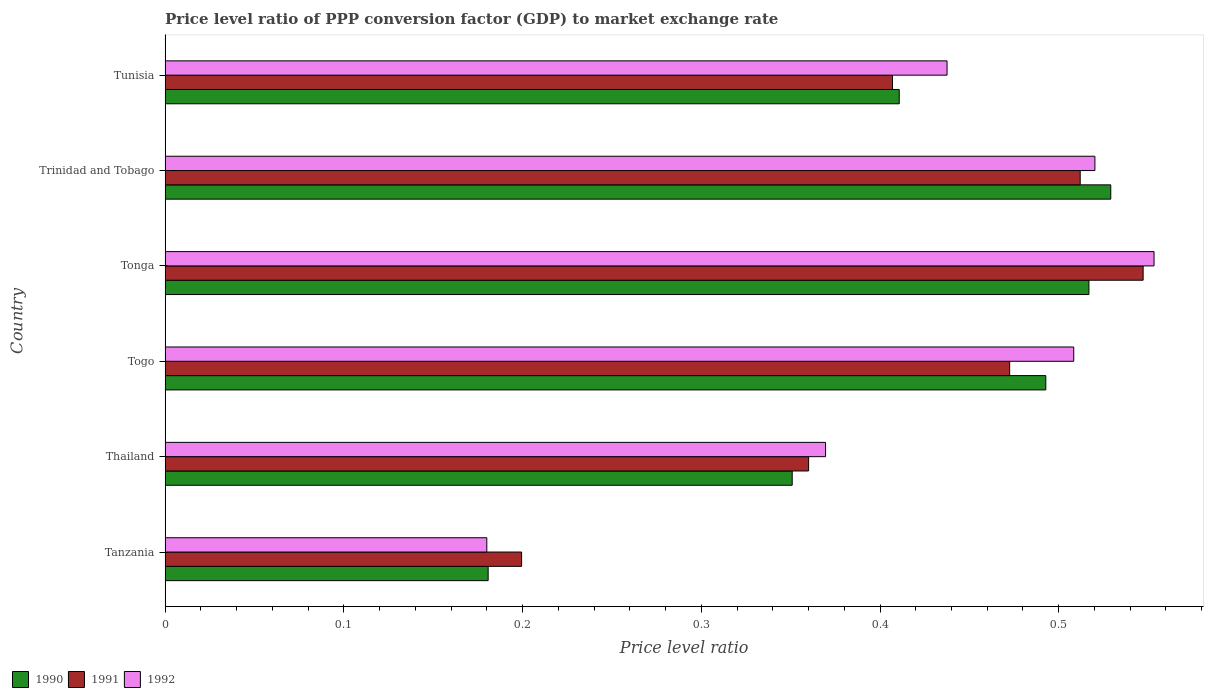How many groups of bars are there?
Your answer should be very brief. 6. Are the number of bars per tick equal to the number of legend labels?
Keep it short and to the point. Yes. Are the number of bars on each tick of the Y-axis equal?
Your response must be concise. Yes. What is the label of the 3rd group of bars from the top?
Ensure brevity in your answer.  Tonga. What is the price level ratio in 1991 in Togo?
Make the answer very short. 0.47. Across all countries, what is the maximum price level ratio in 1992?
Your response must be concise. 0.55. Across all countries, what is the minimum price level ratio in 1991?
Your answer should be very brief. 0.2. In which country was the price level ratio in 1990 maximum?
Offer a terse response. Trinidad and Tobago. In which country was the price level ratio in 1990 minimum?
Ensure brevity in your answer.  Tanzania. What is the total price level ratio in 1990 in the graph?
Your answer should be compact. 2.48. What is the difference between the price level ratio in 1991 in Thailand and that in Tunisia?
Give a very brief answer. -0.05. What is the difference between the price level ratio in 1992 in Tunisia and the price level ratio in 1991 in Trinidad and Tobago?
Keep it short and to the point. -0.07. What is the average price level ratio in 1992 per country?
Ensure brevity in your answer.  0.43. What is the difference between the price level ratio in 1990 and price level ratio in 1992 in Togo?
Ensure brevity in your answer.  -0.02. What is the ratio of the price level ratio in 1990 in Thailand to that in Togo?
Give a very brief answer. 0.71. Is the price level ratio in 1990 in Thailand less than that in Tonga?
Give a very brief answer. Yes. Is the difference between the price level ratio in 1990 in Tanzania and Tonga greater than the difference between the price level ratio in 1992 in Tanzania and Tonga?
Your answer should be compact. Yes. What is the difference between the highest and the second highest price level ratio in 1991?
Your response must be concise. 0.04. What is the difference between the highest and the lowest price level ratio in 1992?
Keep it short and to the point. 0.37. Is the sum of the price level ratio in 1992 in Togo and Trinidad and Tobago greater than the maximum price level ratio in 1991 across all countries?
Your response must be concise. Yes. What does the 3rd bar from the bottom in Tanzania represents?
Your answer should be very brief. 1992. Are all the bars in the graph horizontal?
Make the answer very short. Yes. How many countries are there in the graph?
Keep it short and to the point. 6. What is the difference between two consecutive major ticks on the X-axis?
Provide a short and direct response. 0.1. Does the graph contain any zero values?
Your response must be concise. No. Does the graph contain grids?
Ensure brevity in your answer.  No. Where does the legend appear in the graph?
Your response must be concise. Bottom left. How are the legend labels stacked?
Ensure brevity in your answer.  Horizontal. What is the title of the graph?
Keep it short and to the point. Price level ratio of PPP conversion factor (GDP) to market exchange rate. Does "1975" appear as one of the legend labels in the graph?
Keep it short and to the point. No. What is the label or title of the X-axis?
Give a very brief answer. Price level ratio. What is the label or title of the Y-axis?
Your answer should be very brief. Country. What is the Price level ratio of 1990 in Tanzania?
Make the answer very short. 0.18. What is the Price level ratio of 1991 in Tanzania?
Ensure brevity in your answer.  0.2. What is the Price level ratio in 1992 in Tanzania?
Your answer should be very brief. 0.18. What is the Price level ratio of 1990 in Thailand?
Keep it short and to the point. 0.35. What is the Price level ratio of 1991 in Thailand?
Provide a short and direct response. 0.36. What is the Price level ratio of 1992 in Thailand?
Make the answer very short. 0.37. What is the Price level ratio of 1990 in Togo?
Offer a very short reply. 0.49. What is the Price level ratio of 1991 in Togo?
Give a very brief answer. 0.47. What is the Price level ratio in 1992 in Togo?
Your answer should be compact. 0.51. What is the Price level ratio of 1990 in Tonga?
Ensure brevity in your answer.  0.52. What is the Price level ratio of 1991 in Tonga?
Provide a short and direct response. 0.55. What is the Price level ratio in 1992 in Tonga?
Make the answer very short. 0.55. What is the Price level ratio of 1990 in Trinidad and Tobago?
Offer a terse response. 0.53. What is the Price level ratio in 1991 in Trinidad and Tobago?
Your answer should be compact. 0.51. What is the Price level ratio in 1992 in Trinidad and Tobago?
Provide a succinct answer. 0.52. What is the Price level ratio in 1990 in Tunisia?
Your response must be concise. 0.41. What is the Price level ratio of 1991 in Tunisia?
Offer a very short reply. 0.41. What is the Price level ratio in 1992 in Tunisia?
Provide a short and direct response. 0.44. Across all countries, what is the maximum Price level ratio in 1990?
Offer a terse response. 0.53. Across all countries, what is the maximum Price level ratio of 1991?
Your answer should be very brief. 0.55. Across all countries, what is the maximum Price level ratio of 1992?
Make the answer very short. 0.55. Across all countries, what is the minimum Price level ratio in 1990?
Provide a short and direct response. 0.18. Across all countries, what is the minimum Price level ratio in 1991?
Provide a succinct answer. 0.2. Across all countries, what is the minimum Price level ratio in 1992?
Your answer should be very brief. 0.18. What is the total Price level ratio in 1990 in the graph?
Make the answer very short. 2.48. What is the total Price level ratio of 1991 in the graph?
Provide a short and direct response. 2.5. What is the total Price level ratio of 1992 in the graph?
Provide a succinct answer. 2.57. What is the difference between the Price level ratio of 1990 in Tanzania and that in Thailand?
Provide a short and direct response. -0.17. What is the difference between the Price level ratio of 1991 in Tanzania and that in Thailand?
Keep it short and to the point. -0.16. What is the difference between the Price level ratio in 1992 in Tanzania and that in Thailand?
Offer a terse response. -0.19. What is the difference between the Price level ratio in 1990 in Tanzania and that in Togo?
Your answer should be very brief. -0.31. What is the difference between the Price level ratio of 1991 in Tanzania and that in Togo?
Ensure brevity in your answer.  -0.27. What is the difference between the Price level ratio of 1992 in Tanzania and that in Togo?
Make the answer very short. -0.33. What is the difference between the Price level ratio in 1990 in Tanzania and that in Tonga?
Ensure brevity in your answer.  -0.34. What is the difference between the Price level ratio of 1991 in Tanzania and that in Tonga?
Provide a succinct answer. -0.35. What is the difference between the Price level ratio of 1992 in Tanzania and that in Tonga?
Offer a terse response. -0.37. What is the difference between the Price level ratio of 1990 in Tanzania and that in Trinidad and Tobago?
Make the answer very short. -0.35. What is the difference between the Price level ratio of 1991 in Tanzania and that in Trinidad and Tobago?
Ensure brevity in your answer.  -0.31. What is the difference between the Price level ratio of 1992 in Tanzania and that in Trinidad and Tobago?
Provide a succinct answer. -0.34. What is the difference between the Price level ratio of 1990 in Tanzania and that in Tunisia?
Give a very brief answer. -0.23. What is the difference between the Price level ratio in 1991 in Tanzania and that in Tunisia?
Offer a terse response. -0.21. What is the difference between the Price level ratio in 1992 in Tanzania and that in Tunisia?
Provide a short and direct response. -0.26. What is the difference between the Price level ratio in 1990 in Thailand and that in Togo?
Offer a terse response. -0.14. What is the difference between the Price level ratio in 1991 in Thailand and that in Togo?
Offer a very short reply. -0.11. What is the difference between the Price level ratio in 1992 in Thailand and that in Togo?
Your response must be concise. -0.14. What is the difference between the Price level ratio of 1990 in Thailand and that in Tonga?
Keep it short and to the point. -0.17. What is the difference between the Price level ratio of 1991 in Thailand and that in Tonga?
Your response must be concise. -0.19. What is the difference between the Price level ratio of 1992 in Thailand and that in Tonga?
Your answer should be compact. -0.18. What is the difference between the Price level ratio in 1990 in Thailand and that in Trinidad and Tobago?
Give a very brief answer. -0.18. What is the difference between the Price level ratio of 1991 in Thailand and that in Trinidad and Tobago?
Your response must be concise. -0.15. What is the difference between the Price level ratio in 1992 in Thailand and that in Trinidad and Tobago?
Offer a very short reply. -0.15. What is the difference between the Price level ratio in 1990 in Thailand and that in Tunisia?
Your answer should be compact. -0.06. What is the difference between the Price level ratio in 1991 in Thailand and that in Tunisia?
Your response must be concise. -0.05. What is the difference between the Price level ratio in 1992 in Thailand and that in Tunisia?
Your response must be concise. -0.07. What is the difference between the Price level ratio in 1990 in Togo and that in Tonga?
Offer a very short reply. -0.02. What is the difference between the Price level ratio of 1991 in Togo and that in Tonga?
Offer a terse response. -0.07. What is the difference between the Price level ratio of 1992 in Togo and that in Tonga?
Offer a very short reply. -0.04. What is the difference between the Price level ratio of 1990 in Togo and that in Trinidad and Tobago?
Make the answer very short. -0.04. What is the difference between the Price level ratio in 1991 in Togo and that in Trinidad and Tobago?
Your response must be concise. -0.04. What is the difference between the Price level ratio in 1992 in Togo and that in Trinidad and Tobago?
Provide a short and direct response. -0.01. What is the difference between the Price level ratio in 1990 in Togo and that in Tunisia?
Keep it short and to the point. 0.08. What is the difference between the Price level ratio in 1991 in Togo and that in Tunisia?
Give a very brief answer. 0.07. What is the difference between the Price level ratio in 1992 in Togo and that in Tunisia?
Offer a terse response. 0.07. What is the difference between the Price level ratio of 1990 in Tonga and that in Trinidad and Tobago?
Offer a very short reply. -0.01. What is the difference between the Price level ratio of 1991 in Tonga and that in Trinidad and Tobago?
Offer a very short reply. 0.04. What is the difference between the Price level ratio of 1992 in Tonga and that in Trinidad and Tobago?
Provide a short and direct response. 0.03. What is the difference between the Price level ratio of 1990 in Tonga and that in Tunisia?
Your response must be concise. 0.11. What is the difference between the Price level ratio in 1991 in Tonga and that in Tunisia?
Give a very brief answer. 0.14. What is the difference between the Price level ratio in 1992 in Tonga and that in Tunisia?
Provide a short and direct response. 0.12. What is the difference between the Price level ratio in 1990 in Trinidad and Tobago and that in Tunisia?
Keep it short and to the point. 0.12. What is the difference between the Price level ratio of 1991 in Trinidad and Tobago and that in Tunisia?
Provide a succinct answer. 0.1. What is the difference between the Price level ratio in 1992 in Trinidad and Tobago and that in Tunisia?
Offer a terse response. 0.08. What is the difference between the Price level ratio in 1990 in Tanzania and the Price level ratio in 1991 in Thailand?
Provide a succinct answer. -0.18. What is the difference between the Price level ratio in 1990 in Tanzania and the Price level ratio in 1992 in Thailand?
Your response must be concise. -0.19. What is the difference between the Price level ratio of 1991 in Tanzania and the Price level ratio of 1992 in Thailand?
Give a very brief answer. -0.17. What is the difference between the Price level ratio of 1990 in Tanzania and the Price level ratio of 1991 in Togo?
Your response must be concise. -0.29. What is the difference between the Price level ratio of 1990 in Tanzania and the Price level ratio of 1992 in Togo?
Provide a succinct answer. -0.33. What is the difference between the Price level ratio of 1991 in Tanzania and the Price level ratio of 1992 in Togo?
Provide a short and direct response. -0.31. What is the difference between the Price level ratio in 1990 in Tanzania and the Price level ratio in 1991 in Tonga?
Give a very brief answer. -0.37. What is the difference between the Price level ratio in 1990 in Tanzania and the Price level ratio in 1992 in Tonga?
Your answer should be very brief. -0.37. What is the difference between the Price level ratio in 1991 in Tanzania and the Price level ratio in 1992 in Tonga?
Give a very brief answer. -0.35. What is the difference between the Price level ratio in 1990 in Tanzania and the Price level ratio in 1991 in Trinidad and Tobago?
Keep it short and to the point. -0.33. What is the difference between the Price level ratio of 1990 in Tanzania and the Price level ratio of 1992 in Trinidad and Tobago?
Make the answer very short. -0.34. What is the difference between the Price level ratio of 1991 in Tanzania and the Price level ratio of 1992 in Trinidad and Tobago?
Ensure brevity in your answer.  -0.32. What is the difference between the Price level ratio of 1990 in Tanzania and the Price level ratio of 1991 in Tunisia?
Offer a very short reply. -0.23. What is the difference between the Price level ratio in 1990 in Tanzania and the Price level ratio in 1992 in Tunisia?
Offer a terse response. -0.26. What is the difference between the Price level ratio in 1991 in Tanzania and the Price level ratio in 1992 in Tunisia?
Give a very brief answer. -0.24. What is the difference between the Price level ratio of 1990 in Thailand and the Price level ratio of 1991 in Togo?
Provide a succinct answer. -0.12. What is the difference between the Price level ratio in 1990 in Thailand and the Price level ratio in 1992 in Togo?
Keep it short and to the point. -0.16. What is the difference between the Price level ratio in 1991 in Thailand and the Price level ratio in 1992 in Togo?
Offer a very short reply. -0.15. What is the difference between the Price level ratio of 1990 in Thailand and the Price level ratio of 1991 in Tonga?
Provide a succinct answer. -0.2. What is the difference between the Price level ratio of 1990 in Thailand and the Price level ratio of 1992 in Tonga?
Ensure brevity in your answer.  -0.2. What is the difference between the Price level ratio of 1991 in Thailand and the Price level ratio of 1992 in Tonga?
Make the answer very short. -0.19. What is the difference between the Price level ratio in 1990 in Thailand and the Price level ratio in 1991 in Trinidad and Tobago?
Provide a short and direct response. -0.16. What is the difference between the Price level ratio in 1990 in Thailand and the Price level ratio in 1992 in Trinidad and Tobago?
Give a very brief answer. -0.17. What is the difference between the Price level ratio in 1991 in Thailand and the Price level ratio in 1992 in Trinidad and Tobago?
Offer a very short reply. -0.16. What is the difference between the Price level ratio in 1990 in Thailand and the Price level ratio in 1991 in Tunisia?
Your response must be concise. -0.06. What is the difference between the Price level ratio in 1990 in Thailand and the Price level ratio in 1992 in Tunisia?
Keep it short and to the point. -0.09. What is the difference between the Price level ratio in 1991 in Thailand and the Price level ratio in 1992 in Tunisia?
Your answer should be very brief. -0.08. What is the difference between the Price level ratio of 1990 in Togo and the Price level ratio of 1991 in Tonga?
Give a very brief answer. -0.05. What is the difference between the Price level ratio of 1990 in Togo and the Price level ratio of 1992 in Tonga?
Keep it short and to the point. -0.06. What is the difference between the Price level ratio in 1991 in Togo and the Price level ratio in 1992 in Tonga?
Provide a succinct answer. -0.08. What is the difference between the Price level ratio in 1990 in Togo and the Price level ratio in 1991 in Trinidad and Tobago?
Give a very brief answer. -0.02. What is the difference between the Price level ratio in 1990 in Togo and the Price level ratio in 1992 in Trinidad and Tobago?
Provide a short and direct response. -0.03. What is the difference between the Price level ratio in 1991 in Togo and the Price level ratio in 1992 in Trinidad and Tobago?
Keep it short and to the point. -0.05. What is the difference between the Price level ratio of 1990 in Togo and the Price level ratio of 1991 in Tunisia?
Make the answer very short. 0.09. What is the difference between the Price level ratio in 1990 in Togo and the Price level ratio in 1992 in Tunisia?
Ensure brevity in your answer.  0.06. What is the difference between the Price level ratio of 1991 in Togo and the Price level ratio of 1992 in Tunisia?
Give a very brief answer. 0.04. What is the difference between the Price level ratio of 1990 in Tonga and the Price level ratio of 1991 in Trinidad and Tobago?
Your response must be concise. 0. What is the difference between the Price level ratio in 1990 in Tonga and the Price level ratio in 1992 in Trinidad and Tobago?
Offer a terse response. -0. What is the difference between the Price level ratio of 1991 in Tonga and the Price level ratio of 1992 in Trinidad and Tobago?
Offer a very short reply. 0.03. What is the difference between the Price level ratio of 1990 in Tonga and the Price level ratio of 1991 in Tunisia?
Offer a terse response. 0.11. What is the difference between the Price level ratio in 1990 in Tonga and the Price level ratio in 1992 in Tunisia?
Make the answer very short. 0.08. What is the difference between the Price level ratio in 1991 in Tonga and the Price level ratio in 1992 in Tunisia?
Keep it short and to the point. 0.11. What is the difference between the Price level ratio of 1990 in Trinidad and Tobago and the Price level ratio of 1991 in Tunisia?
Offer a very short reply. 0.12. What is the difference between the Price level ratio of 1990 in Trinidad and Tobago and the Price level ratio of 1992 in Tunisia?
Provide a succinct answer. 0.09. What is the difference between the Price level ratio of 1991 in Trinidad and Tobago and the Price level ratio of 1992 in Tunisia?
Your response must be concise. 0.07. What is the average Price level ratio of 1990 per country?
Ensure brevity in your answer.  0.41. What is the average Price level ratio of 1991 per country?
Provide a succinct answer. 0.42. What is the average Price level ratio of 1992 per country?
Make the answer very short. 0.43. What is the difference between the Price level ratio of 1990 and Price level ratio of 1991 in Tanzania?
Make the answer very short. -0.02. What is the difference between the Price level ratio of 1990 and Price level ratio of 1992 in Tanzania?
Provide a short and direct response. 0. What is the difference between the Price level ratio of 1991 and Price level ratio of 1992 in Tanzania?
Provide a succinct answer. 0.02. What is the difference between the Price level ratio of 1990 and Price level ratio of 1991 in Thailand?
Make the answer very short. -0.01. What is the difference between the Price level ratio in 1990 and Price level ratio in 1992 in Thailand?
Provide a short and direct response. -0.02. What is the difference between the Price level ratio of 1991 and Price level ratio of 1992 in Thailand?
Offer a very short reply. -0.01. What is the difference between the Price level ratio of 1990 and Price level ratio of 1991 in Togo?
Make the answer very short. 0.02. What is the difference between the Price level ratio of 1990 and Price level ratio of 1992 in Togo?
Keep it short and to the point. -0.02. What is the difference between the Price level ratio of 1991 and Price level ratio of 1992 in Togo?
Give a very brief answer. -0.04. What is the difference between the Price level ratio in 1990 and Price level ratio in 1991 in Tonga?
Your answer should be very brief. -0.03. What is the difference between the Price level ratio of 1990 and Price level ratio of 1992 in Tonga?
Your response must be concise. -0.04. What is the difference between the Price level ratio of 1991 and Price level ratio of 1992 in Tonga?
Ensure brevity in your answer.  -0.01. What is the difference between the Price level ratio in 1990 and Price level ratio in 1991 in Trinidad and Tobago?
Your response must be concise. 0.02. What is the difference between the Price level ratio in 1990 and Price level ratio in 1992 in Trinidad and Tobago?
Provide a succinct answer. 0.01. What is the difference between the Price level ratio of 1991 and Price level ratio of 1992 in Trinidad and Tobago?
Your answer should be very brief. -0.01. What is the difference between the Price level ratio of 1990 and Price level ratio of 1991 in Tunisia?
Your answer should be compact. 0. What is the difference between the Price level ratio in 1990 and Price level ratio in 1992 in Tunisia?
Keep it short and to the point. -0.03. What is the difference between the Price level ratio in 1991 and Price level ratio in 1992 in Tunisia?
Provide a short and direct response. -0.03. What is the ratio of the Price level ratio in 1990 in Tanzania to that in Thailand?
Your answer should be compact. 0.52. What is the ratio of the Price level ratio of 1991 in Tanzania to that in Thailand?
Keep it short and to the point. 0.55. What is the ratio of the Price level ratio in 1992 in Tanzania to that in Thailand?
Your answer should be compact. 0.49. What is the ratio of the Price level ratio in 1990 in Tanzania to that in Togo?
Make the answer very short. 0.37. What is the ratio of the Price level ratio in 1991 in Tanzania to that in Togo?
Ensure brevity in your answer.  0.42. What is the ratio of the Price level ratio in 1992 in Tanzania to that in Togo?
Offer a very short reply. 0.35. What is the ratio of the Price level ratio in 1990 in Tanzania to that in Tonga?
Offer a very short reply. 0.35. What is the ratio of the Price level ratio in 1991 in Tanzania to that in Tonga?
Ensure brevity in your answer.  0.36. What is the ratio of the Price level ratio in 1992 in Tanzania to that in Tonga?
Keep it short and to the point. 0.33. What is the ratio of the Price level ratio of 1990 in Tanzania to that in Trinidad and Tobago?
Your response must be concise. 0.34. What is the ratio of the Price level ratio of 1991 in Tanzania to that in Trinidad and Tobago?
Your answer should be compact. 0.39. What is the ratio of the Price level ratio in 1992 in Tanzania to that in Trinidad and Tobago?
Provide a short and direct response. 0.35. What is the ratio of the Price level ratio in 1990 in Tanzania to that in Tunisia?
Your response must be concise. 0.44. What is the ratio of the Price level ratio in 1991 in Tanzania to that in Tunisia?
Your answer should be compact. 0.49. What is the ratio of the Price level ratio in 1992 in Tanzania to that in Tunisia?
Your answer should be compact. 0.41. What is the ratio of the Price level ratio of 1990 in Thailand to that in Togo?
Provide a succinct answer. 0.71. What is the ratio of the Price level ratio of 1991 in Thailand to that in Togo?
Offer a terse response. 0.76. What is the ratio of the Price level ratio in 1992 in Thailand to that in Togo?
Provide a short and direct response. 0.73. What is the ratio of the Price level ratio of 1990 in Thailand to that in Tonga?
Keep it short and to the point. 0.68. What is the ratio of the Price level ratio in 1991 in Thailand to that in Tonga?
Your answer should be very brief. 0.66. What is the ratio of the Price level ratio of 1992 in Thailand to that in Tonga?
Provide a succinct answer. 0.67. What is the ratio of the Price level ratio of 1990 in Thailand to that in Trinidad and Tobago?
Offer a terse response. 0.66. What is the ratio of the Price level ratio of 1991 in Thailand to that in Trinidad and Tobago?
Keep it short and to the point. 0.7. What is the ratio of the Price level ratio of 1992 in Thailand to that in Trinidad and Tobago?
Give a very brief answer. 0.71. What is the ratio of the Price level ratio of 1990 in Thailand to that in Tunisia?
Keep it short and to the point. 0.85. What is the ratio of the Price level ratio of 1991 in Thailand to that in Tunisia?
Offer a very short reply. 0.88. What is the ratio of the Price level ratio of 1992 in Thailand to that in Tunisia?
Provide a short and direct response. 0.84. What is the ratio of the Price level ratio in 1990 in Togo to that in Tonga?
Provide a short and direct response. 0.95. What is the ratio of the Price level ratio of 1991 in Togo to that in Tonga?
Provide a short and direct response. 0.86. What is the ratio of the Price level ratio of 1992 in Togo to that in Tonga?
Make the answer very short. 0.92. What is the ratio of the Price level ratio in 1990 in Togo to that in Trinidad and Tobago?
Your answer should be compact. 0.93. What is the ratio of the Price level ratio in 1991 in Togo to that in Trinidad and Tobago?
Your response must be concise. 0.92. What is the ratio of the Price level ratio of 1992 in Togo to that in Trinidad and Tobago?
Offer a very short reply. 0.98. What is the ratio of the Price level ratio of 1990 in Togo to that in Tunisia?
Keep it short and to the point. 1.2. What is the ratio of the Price level ratio of 1991 in Togo to that in Tunisia?
Ensure brevity in your answer.  1.16. What is the ratio of the Price level ratio of 1992 in Togo to that in Tunisia?
Your answer should be very brief. 1.16. What is the ratio of the Price level ratio of 1990 in Tonga to that in Trinidad and Tobago?
Your answer should be very brief. 0.98. What is the ratio of the Price level ratio of 1991 in Tonga to that in Trinidad and Tobago?
Provide a succinct answer. 1.07. What is the ratio of the Price level ratio in 1992 in Tonga to that in Trinidad and Tobago?
Provide a succinct answer. 1.06. What is the ratio of the Price level ratio of 1990 in Tonga to that in Tunisia?
Give a very brief answer. 1.26. What is the ratio of the Price level ratio in 1991 in Tonga to that in Tunisia?
Provide a succinct answer. 1.34. What is the ratio of the Price level ratio in 1992 in Tonga to that in Tunisia?
Keep it short and to the point. 1.26. What is the ratio of the Price level ratio of 1990 in Trinidad and Tobago to that in Tunisia?
Your answer should be compact. 1.29. What is the ratio of the Price level ratio of 1991 in Trinidad and Tobago to that in Tunisia?
Provide a succinct answer. 1.26. What is the ratio of the Price level ratio in 1992 in Trinidad and Tobago to that in Tunisia?
Your response must be concise. 1.19. What is the difference between the highest and the second highest Price level ratio of 1990?
Provide a succinct answer. 0.01. What is the difference between the highest and the second highest Price level ratio of 1991?
Your response must be concise. 0.04. What is the difference between the highest and the second highest Price level ratio in 1992?
Your answer should be very brief. 0.03. What is the difference between the highest and the lowest Price level ratio of 1990?
Keep it short and to the point. 0.35. What is the difference between the highest and the lowest Price level ratio of 1991?
Provide a short and direct response. 0.35. What is the difference between the highest and the lowest Price level ratio in 1992?
Provide a short and direct response. 0.37. 